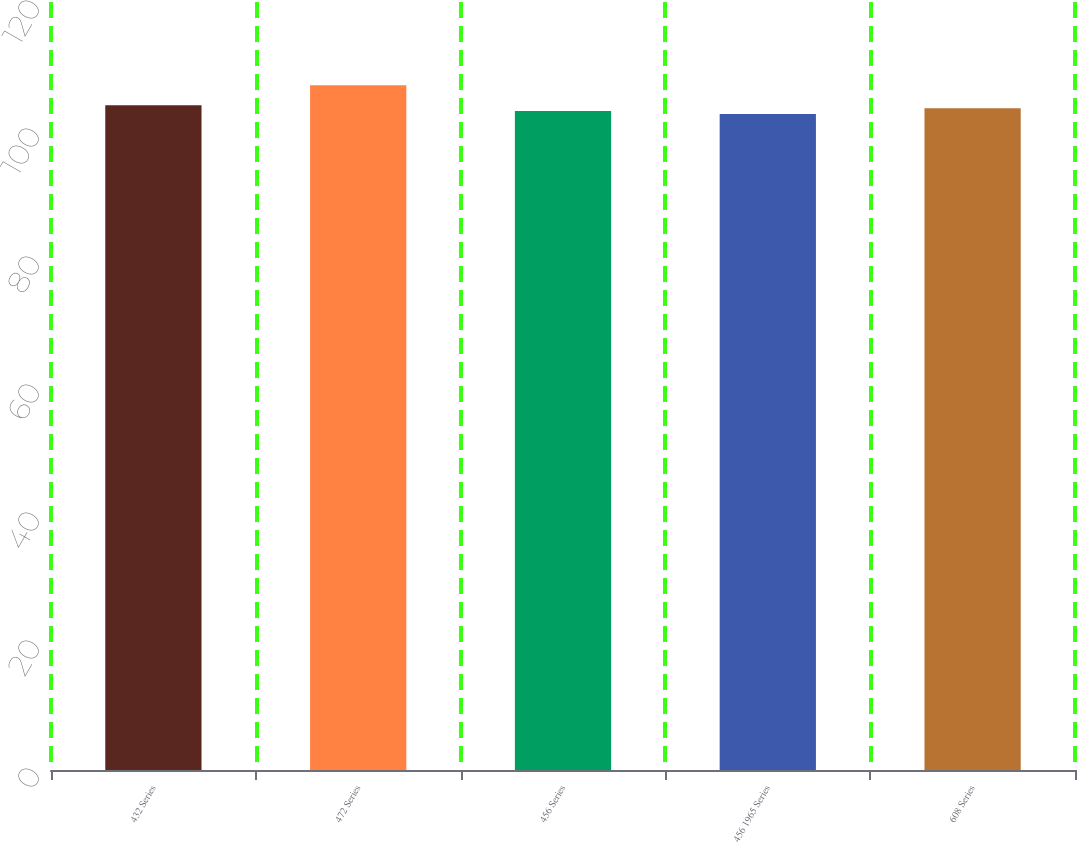<chart> <loc_0><loc_0><loc_500><loc_500><bar_chart><fcel>432 Series<fcel>472 Series<fcel>456 Series<fcel>456 1965 Series<fcel>608 Series<nl><fcel>103.85<fcel>107<fcel>102.95<fcel>102.5<fcel>103.4<nl></chart> 